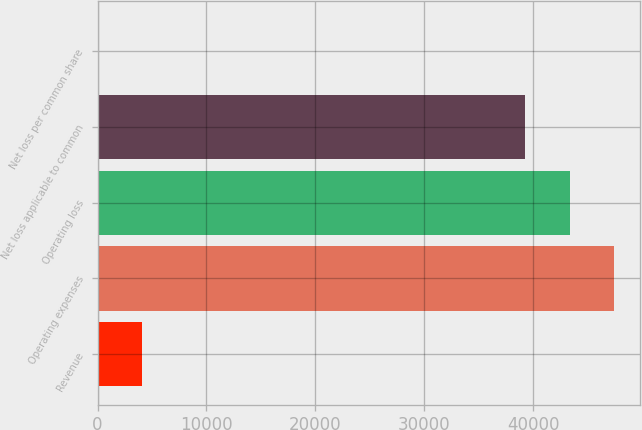Convert chart. <chart><loc_0><loc_0><loc_500><loc_500><bar_chart><fcel>Revenue<fcel>Operating expenses<fcel>Operating loss<fcel>Net loss applicable to common<fcel>Net loss per common share<nl><fcel>4108.57<fcel>47464.8<fcel>43357.4<fcel>39250<fcel>1.19<nl></chart> 